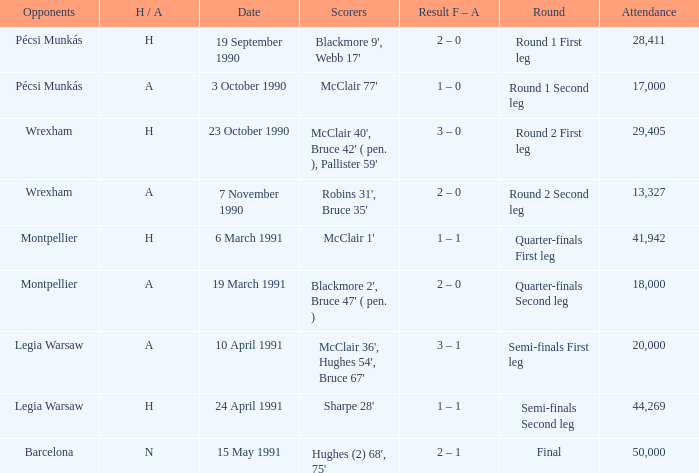What is the lowest attendance when the h/A is H in the Semi-Finals Second Leg? 44269.0. Would you be able to parse every entry in this table? {'header': ['Opponents', 'H / A', 'Date', 'Scorers', 'Result F – A', 'Round', 'Attendance'], 'rows': [['Pécsi Munkás', 'H', '19 September 1990', "Blackmore 9', Webb 17'", '2 – 0', 'Round 1 First leg', '28,411'], ['Pécsi Munkás', 'A', '3 October 1990', "McClair 77'", '1 – 0', 'Round 1 Second leg', '17,000'], ['Wrexham', 'H', '23 October 1990', "McClair 40', Bruce 42' ( pen. ), Pallister 59'", '3 – 0', 'Round 2 First leg', '29,405'], ['Wrexham', 'A', '7 November 1990', "Robins 31', Bruce 35'", '2 – 0', 'Round 2 Second leg', '13,327'], ['Montpellier', 'H', '6 March 1991', "McClair 1'", '1 – 1', 'Quarter-finals First leg', '41,942'], ['Montpellier', 'A', '19 March 1991', "Blackmore 2', Bruce 47' ( pen. )", '2 – 0', 'Quarter-finals Second leg', '18,000'], ['Legia Warsaw', 'A', '10 April 1991', "McClair 36', Hughes 54', Bruce 67'", '3 – 1', 'Semi-finals First leg', '20,000'], ['Legia Warsaw', 'H', '24 April 1991', "Sharpe 28'", '1 – 1', 'Semi-finals Second leg', '44,269'], ['Barcelona', 'N', '15 May 1991', "Hughes (2) 68', 75'", '2 – 1', 'Final', '50,000']]} 